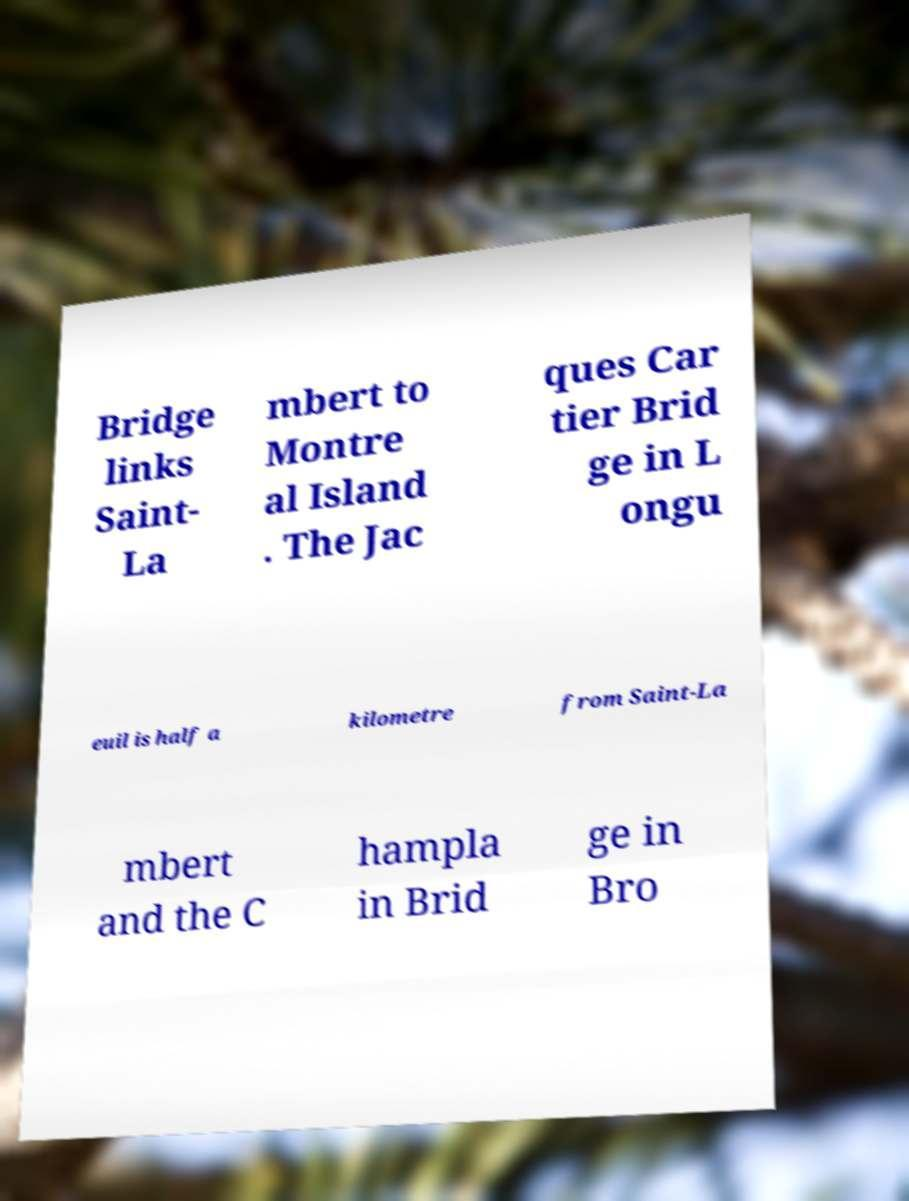Could you extract and type out the text from this image? Bridge links Saint- La mbert to Montre al Island . The Jac ques Car tier Brid ge in L ongu euil is half a kilometre from Saint-La mbert and the C hampla in Brid ge in Bro 